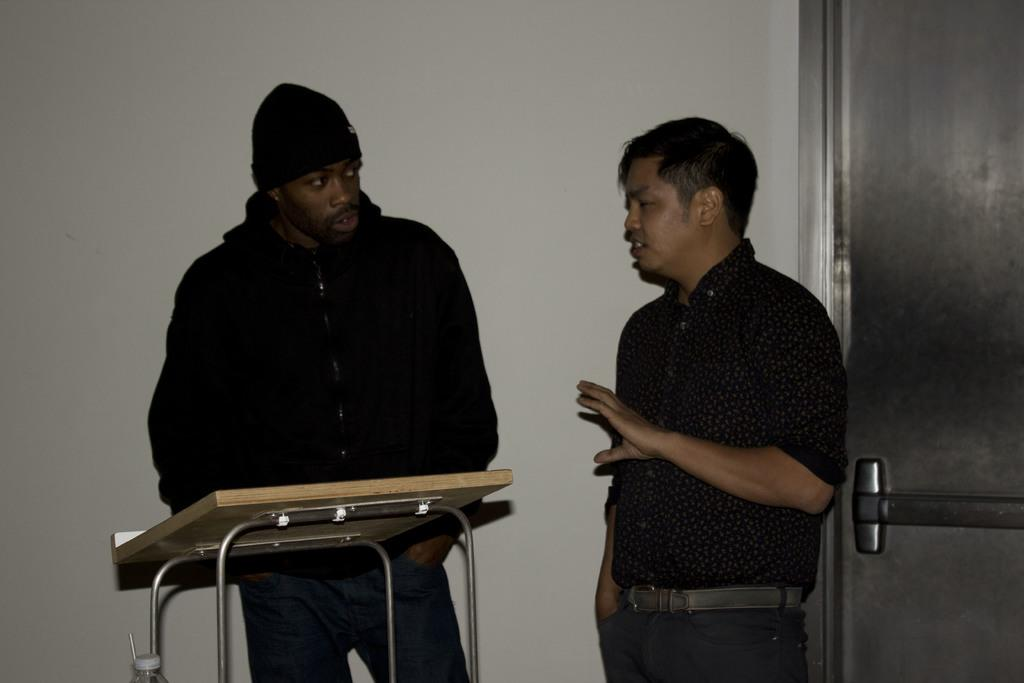How many people are in the image? There are two persons in the image. What is the main object in the image besides the people? There is a table in the image. What can be seen on the table? There is a bottle in the image. What architectural features are present in the image? There is a door and a wall in the image. What type of pet can be seen playing with a fowl in the image? There is no pet or fowl present in the image. What kind of fuel is being used by the vehicle in the image? There is no vehicle present in the image, so it is not possible to determine what type of fuel is being used. 